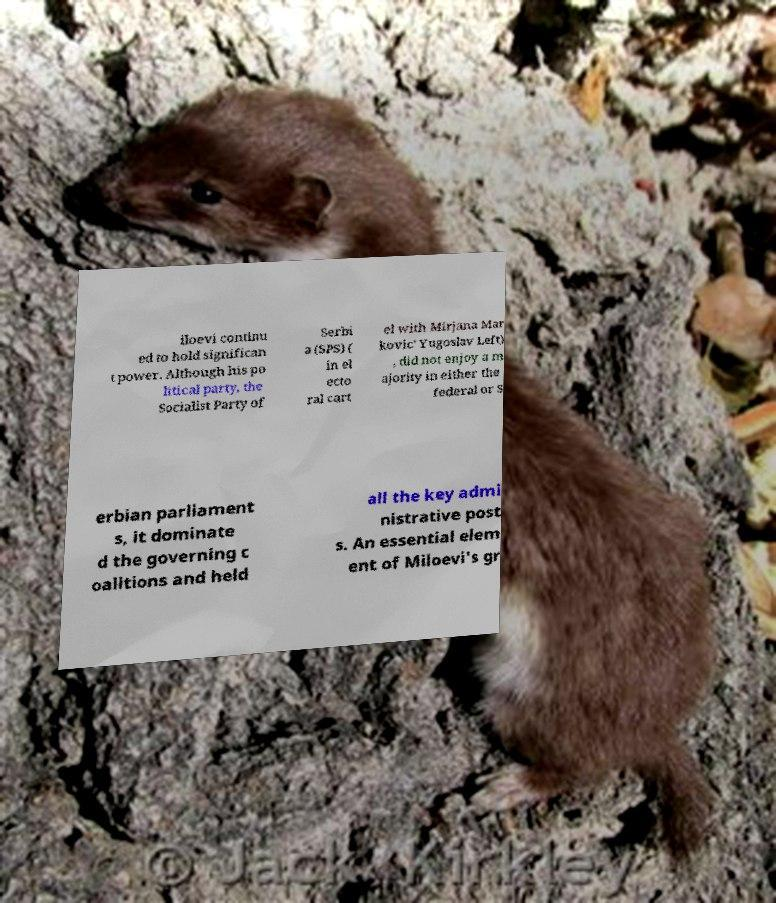For documentation purposes, I need the text within this image transcribed. Could you provide that? iloevi continu ed to hold significan t power. Although his po litical party, the Socialist Party of Serbi a (SPS) ( in el ecto ral cart el with Mirjana Mar kovic' Yugoslav Left) , did not enjoy a m ajority in either the federal or S erbian parliament s, it dominate d the governing c oalitions and held all the key admi nistrative post s. An essential elem ent of Miloevi's gr 